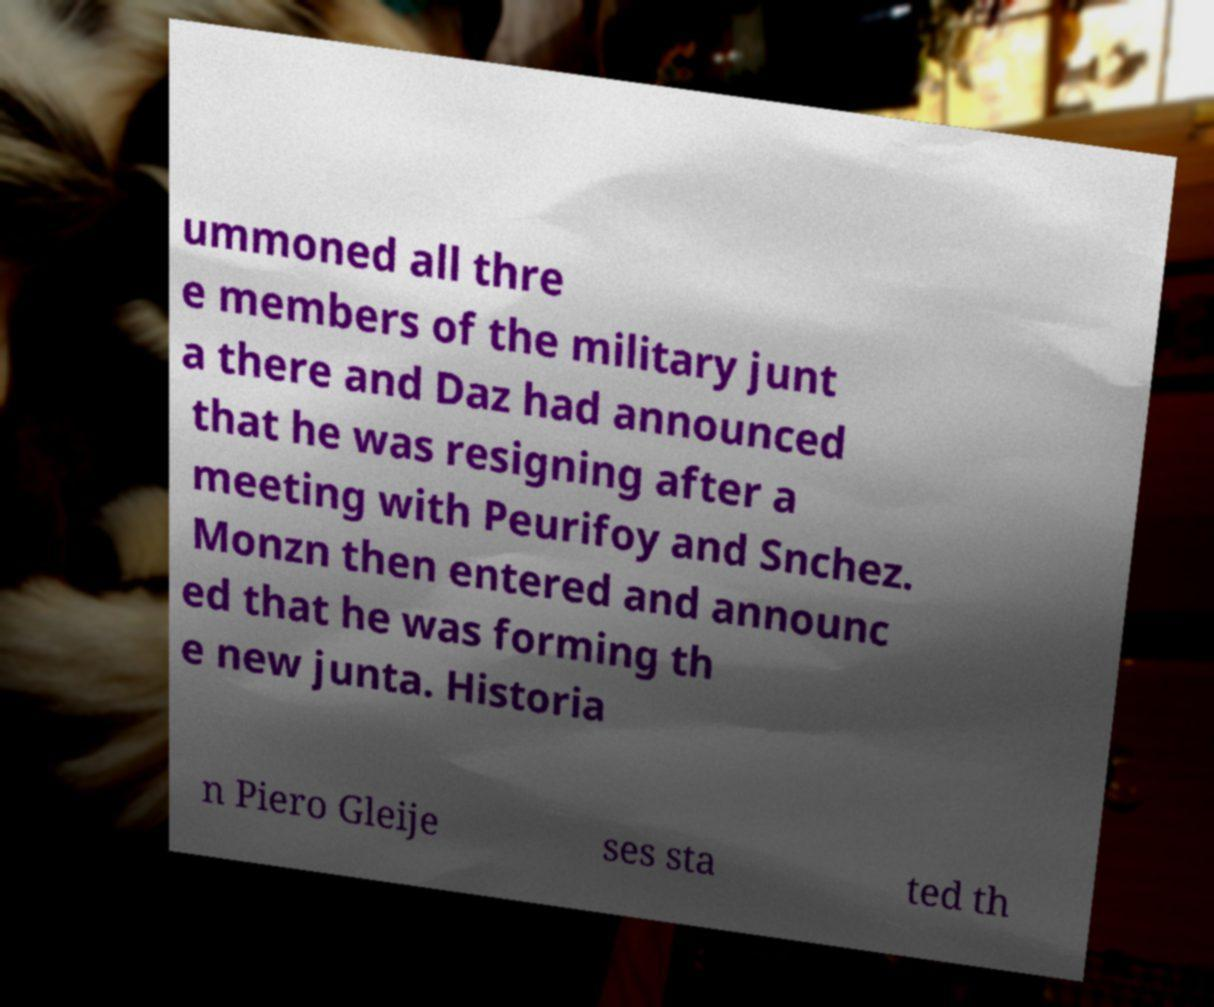Can you accurately transcribe the text from the provided image for me? ummoned all thre e members of the military junt a there and Daz had announced that he was resigning after a meeting with Peurifoy and Snchez. Monzn then entered and announc ed that he was forming th e new junta. Historia n Piero Gleije ses sta ted th 